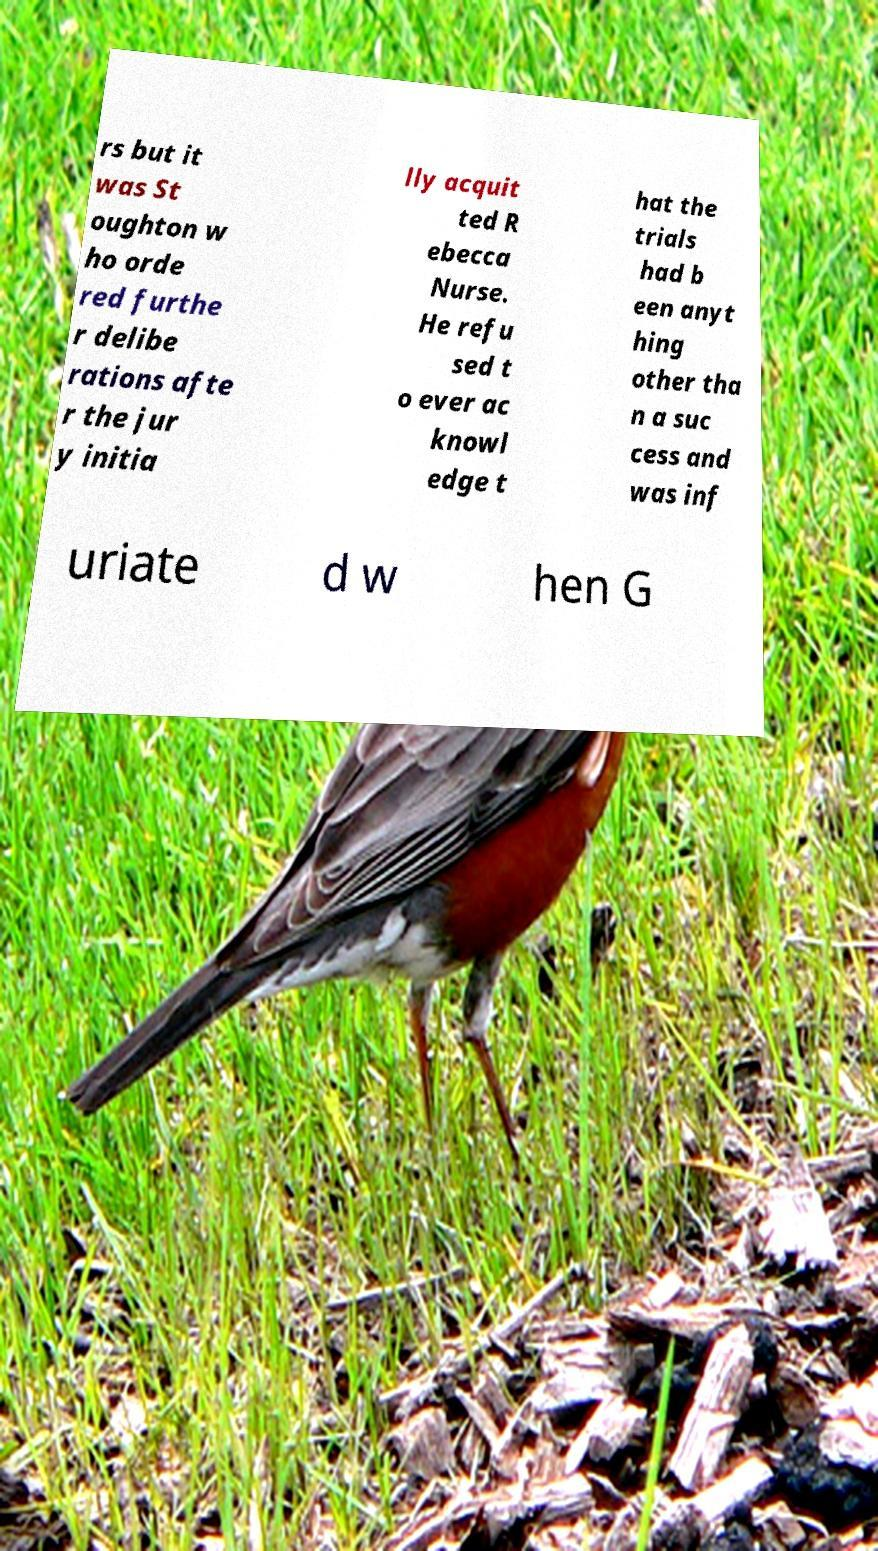There's text embedded in this image that I need extracted. Can you transcribe it verbatim? rs but it was St oughton w ho orde red furthe r delibe rations afte r the jur y initia lly acquit ted R ebecca Nurse. He refu sed t o ever ac knowl edge t hat the trials had b een anyt hing other tha n a suc cess and was inf uriate d w hen G 